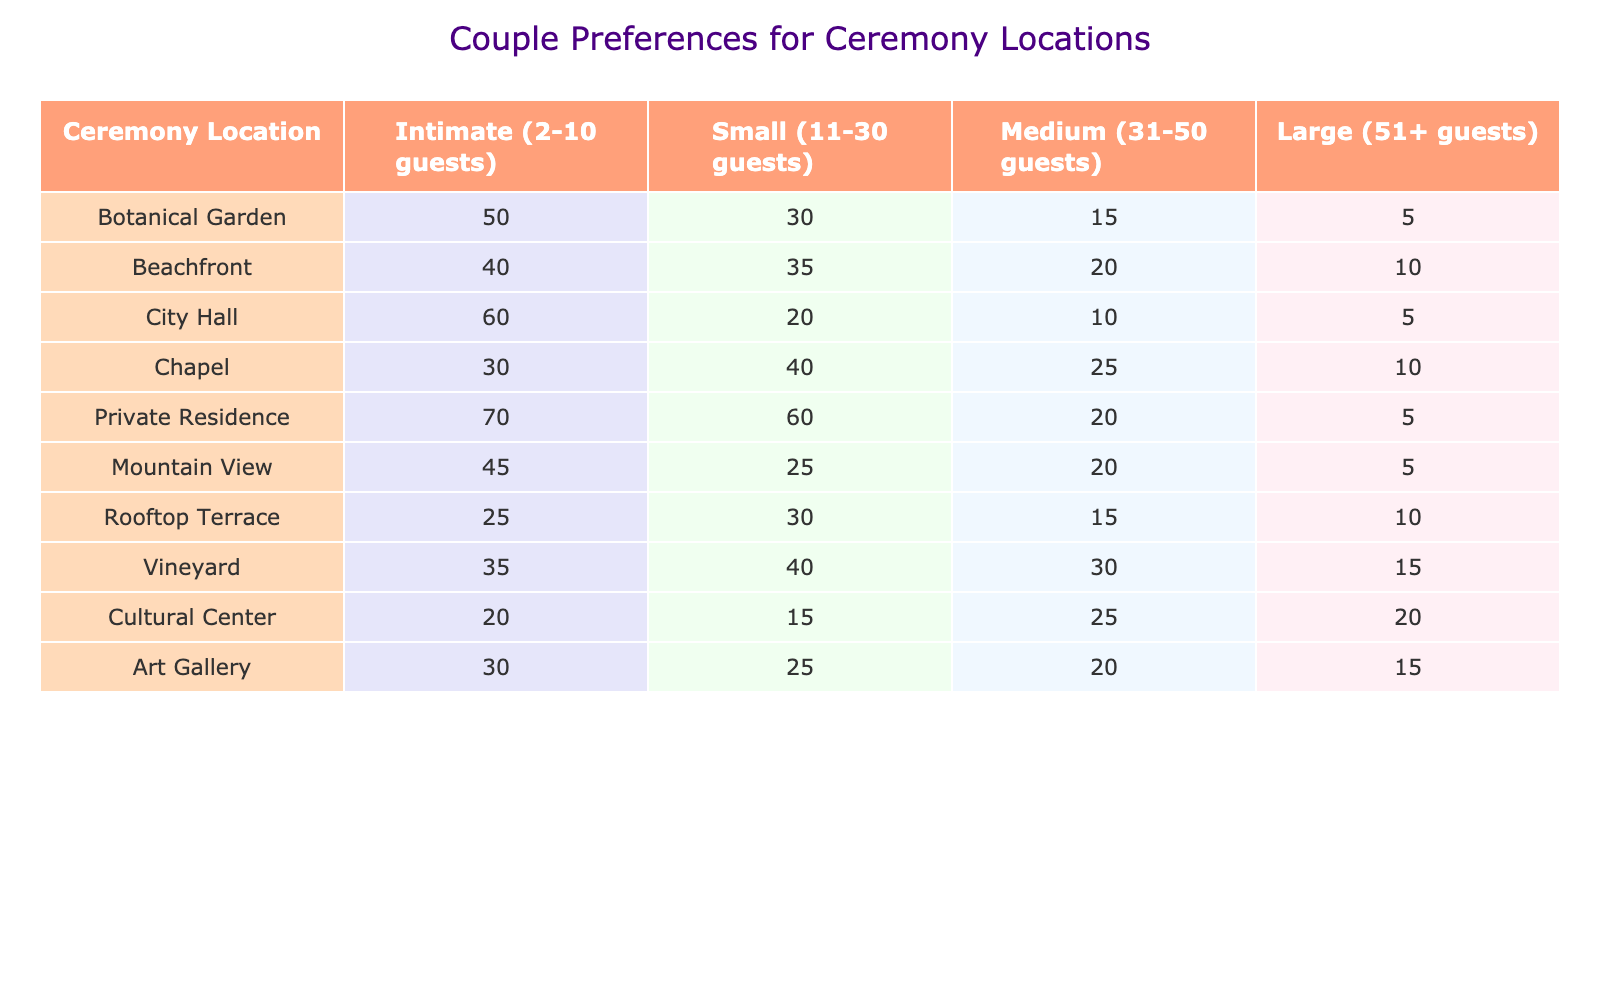What is the most preferred location for intimate weddings? The table shows that the most preferred location for intimate weddings (2-10 guests) is a Private Residence, with a total of 70 preferences.
Answer: Private Residence Which location has the fewest preferences for large weddings? Looking at the "Large (51+ guests)" column, City Hall has the fewest preferences with a total of 5.
Answer: City Hall What is the total number of preferences for small weddings at chapels and vineyards combined? For chapels, the total for small weddings is 40 and for vineyards, it is 40. Adding these together gives 40 + 40 = 80.
Answer: 80 Is the preference for beachfront ceremonies greater than that for art gallery ceremonies for medium-sized weddings? The preference for beachfront ceremonies for medium-sized weddings is 20, while for art gallery ceremonies it's 20 too. So, it’s equal, not greater.
Answer: No What is the average preference for all ceremony locations for medium-sized weddings? To find the average for medium-sized weddings, we sum the values: 15 + 20 + 10 + 25 + 20 + 20 + 15 + 30 + 25 + 20 = 190. Since there are 10 locations, the average is 190/10 = 19.
Answer: 19 How many couples prefer city hall ceremonies for small weddings? From the table, it indicates that there are 20 preferences for small weddings at City Hall.
Answer: 20 Which location has the highest total preference across all wedding sizes? By adding up the preferences for each location, we find that the Private Residence has a total of 70 + 60 + 20 + 5 = 155, which is the highest among all locations.
Answer: Private Residence Is the preference for intimate weddings at Botanical Garden higher than the preference for small weddings at Mountain View? The preference at Botanical Garden for intimate weddings is 50, and for Mountain View for small weddings it’s 25. Therefore, it is higher.
Answer: Yes 